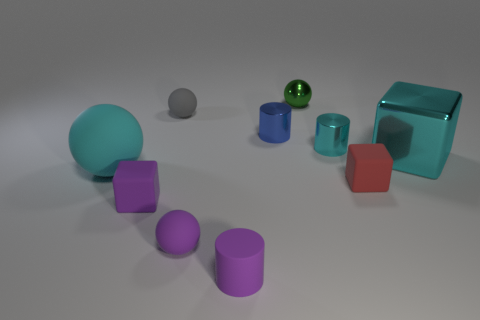There is a large object that is the same shape as the small gray object; what is its color?
Your answer should be very brief. Cyan. What number of small metallic things are the same color as the big block?
Provide a short and direct response. 1. What number of objects are either blocks on the right side of the tiny red block or large cyan rubber things?
Keep it short and to the point. 2. How big is the matte ball that is behind the cyan metal block?
Offer a terse response. Small. Is the number of rubber cylinders less than the number of large green shiny blocks?
Your answer should be very brief. No. Does the tiny block to the left of the green shiny ball have the same material as the large object left of the gray matte ball?
Your answer should be compact. Yes. The big thing right of the metal cylinder that is behind the cyan metal thing to the left of the cyan metal block is what shape?
Ensure brevity in your answer.  Cube. What number of small purple objects are the same material as the small cyan object?
Your answer should be very brief. 0. There is a tiny blue metal cylinder to the right of the cyan matte ball; what number of green things are behind it?
Your answer should be compact. 1. Does the big thing to the right of the tiny gray thing have the same color as the block that is on the left side of the red rubber thing?
Your answer should be compact. No. 